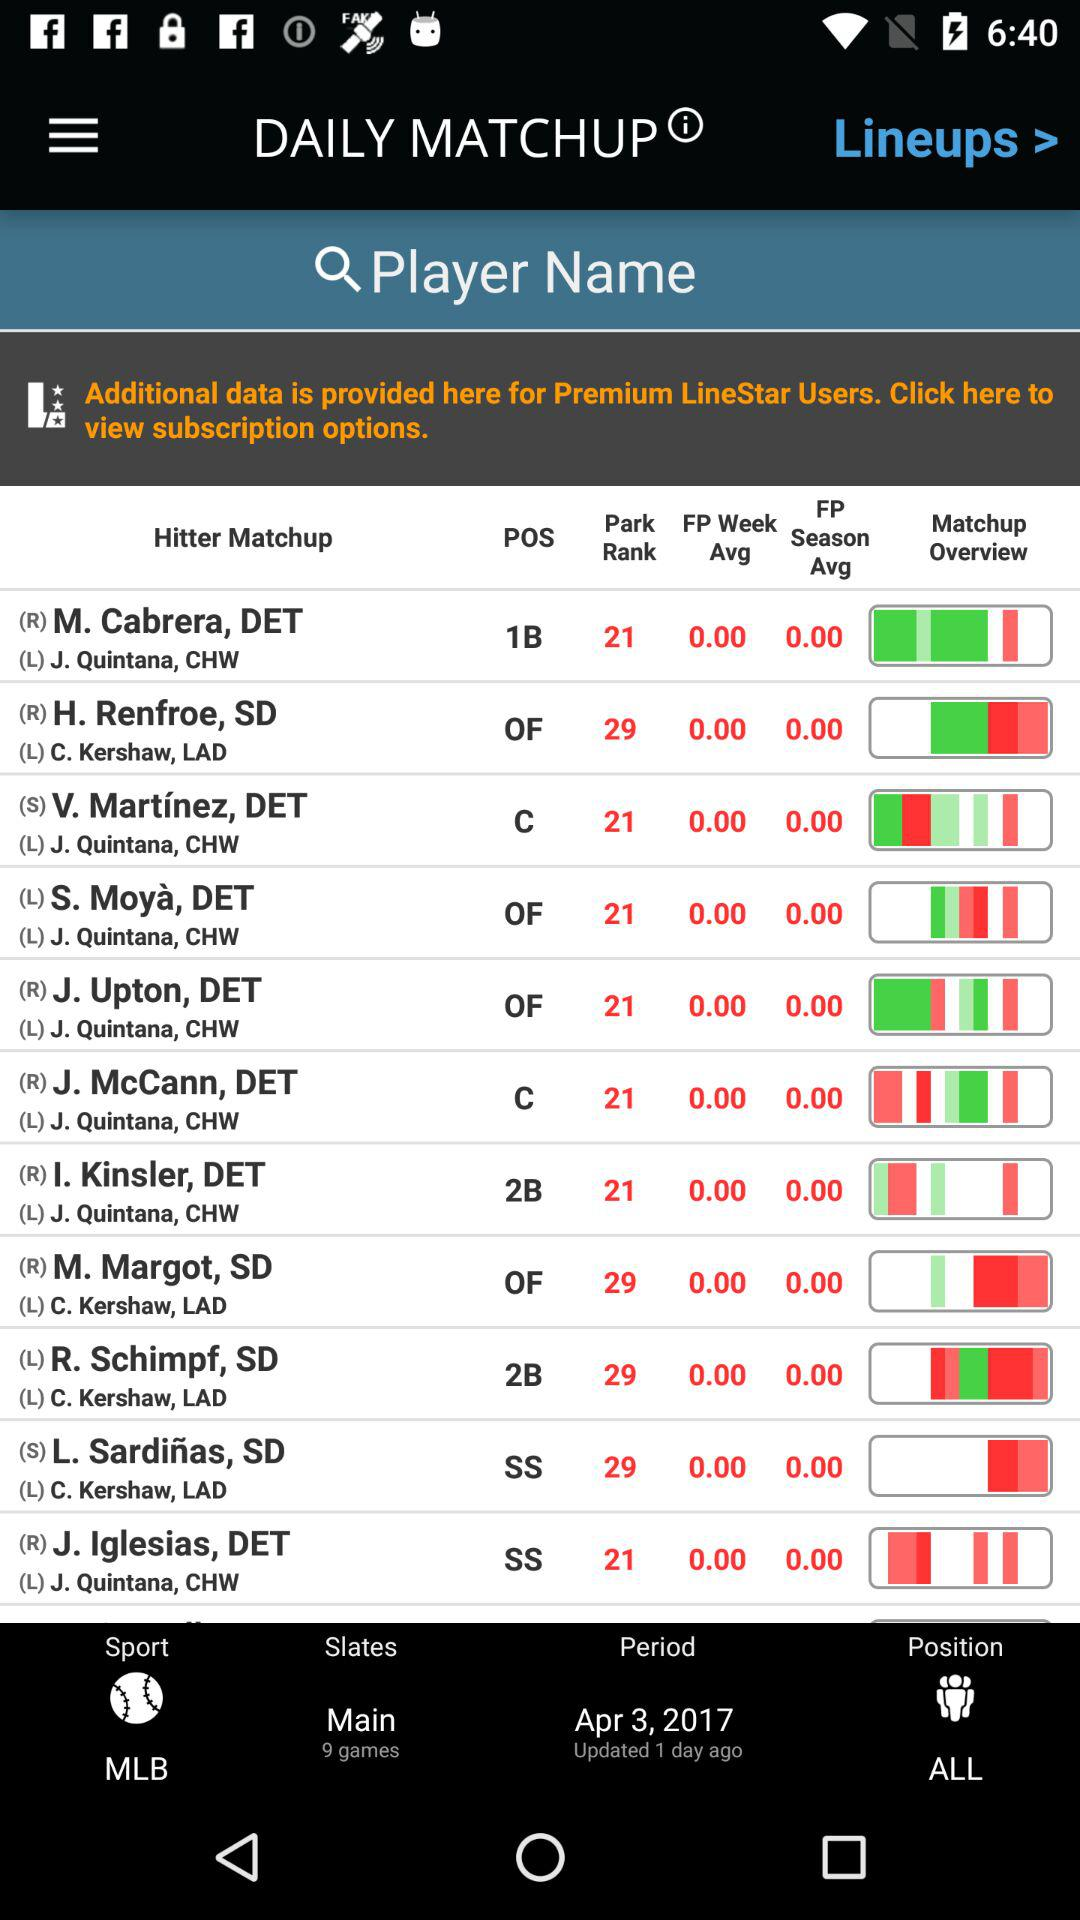What is the date of period? The date of period is April 3, 2017. 